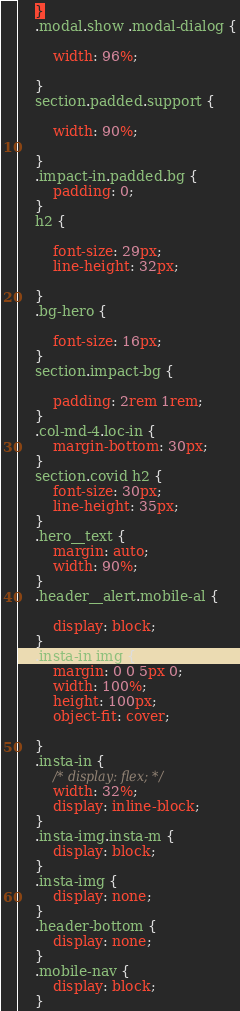Convert code to text. <code><loc_0><loc_0><loc_500><loc_500><_CSS_>    }
    .modal.show .modal-dialog {

        width: 96%;

    }
    section.padded.support {

        width: 90%;

    }
    .impact-in.padded.bg {
        padding: 0;
    }
    h2 {

        font-size: 29px;
        line-height: 32px;

    }
    .bg-hero {

        font-size: 16px;
    }
    section.impact-bg {

        padding: 2rem 1rem;
    }
    .col-md-4.loc-in {
        margin-bottom: 30px;
    }
    section.covid h2 {
        font-size: 30px;
        line-height: 35px;
    }
    .hero__text {
        margin: auto;
        width: 90%;
    }
    .header__alert.mobile-al {

        display: block;
    }
    .insta-in img {
        margin: 0 0 5px 0;
        width: 100%;
        height: 100px;
        object-fit: cover;

    }
    .insta-in {
        /* display: flex; */
        width: 32%;
        display: inline-block;
    }
    .insta-img.insta-m {
        display: block;
    }
    .insta-img {
        display: none;
    }
    .header-bottom {
        display: none;
    }
    .mobile-nav {
        display: block;
    }</code> 